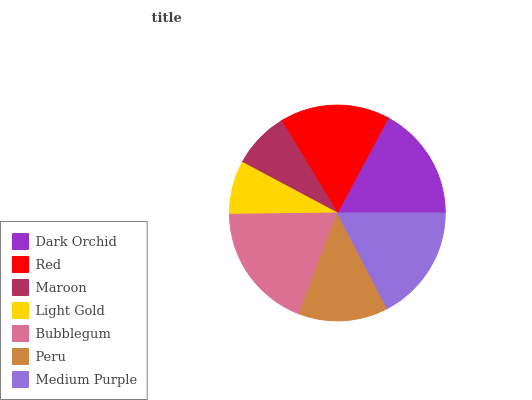Is Light Gold the minimum?
Answer yes or no. Yes. Is Bubblegum the maximum?
Answer yes or no. Yes. Is Red the minimum?
Answer yes or no. No. Is Red the maximum?
Answer yes or no. No. Is Dark Orchid greater than Red?
Answer yes or no. Yes. Is Red less than Dark Orchid?
Answer yes or no. Yes. Is Red greater than Dark Orchid?
Answer yes or no. No. Is Dark Orchid less than Red?
Answer yes or no. No. Is Red the high median?
Answer yes or no. Yes. Is Red the low median?
Answer yes or no. Yes. Is Peru the high median?
Answer yes or no. No. Is Bubblegum the low median?
Answer yes or no. No. 